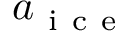<formula> <loc_0><loc_0><loc_500><loc_500>a _ { i c e }</formula> 